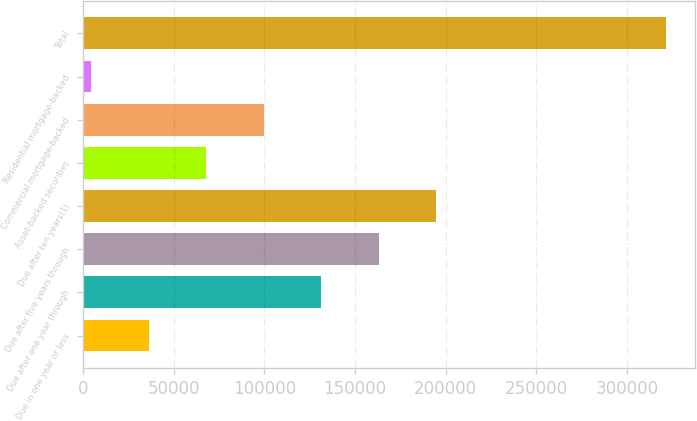Convert chart to OTSL. <chart><loc_0><loc_0><loc_500><loc_500><bar_chart><fcel>Due in one year or less<fcel>Due after one year through<fcel>Due after five years through<fcel>Due after ten years(1)<fcel>Asset-backed securities<fcel>Commercial mortgage-backed<fcel>Residential mortgage-backed<fcel>Total<nl><fcel>36220.7<fcel>131287<fcel>162976<fcel>194664<fcel>67909.4<fcel>99598.1<fcel>4532<fcel>321419<nl></chart> 